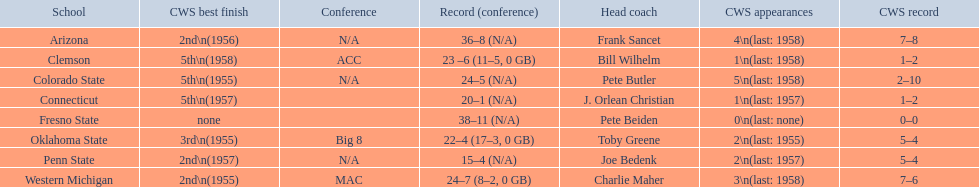What are all of the schools? Arizona, Clemson, Colorado State, Connecticut, Fresno State, Oklahoma State, Penn State, Western Michigan. Which team had fewer than 20 wins? Penn State. 